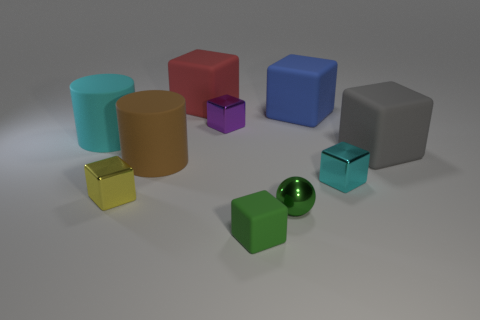Subtract all blue cubes. How many cubes are left? 6 Subtract 5 cubes. How many cubes are left? 2 Subtract all purple blocks. How many blocks are left? 6 Subtract all gray cubes. Subtract all yellow balls. How many cubes are left? 6 Subtract all blocks. How many objects are left? 3 Subtract all green things. Subtract all brown metal objects. How many objects are left? 8 Add 8 cyan objects. How many cyan objects are left? 10 Add 8 large green cylinders. How many large green cylinders exist? 8 Subtract 1 green spheres. How many objects are left? 9 